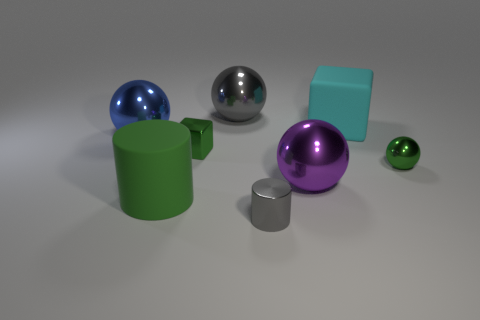Add 1 big yellow balls. How many objects exist? 9 Subtract all blocks. How many objects are left? 6 Subtract all small shiny cubes. Subtract all green metal blocks. How many objects are left? 6 Add 7 gray things. How many gray things are left? 9 Add 1 small cyan metallic balls. How many small cyan metallic balls exist? 1 Subtract 1 green cylinders. How many objects are left? 7 